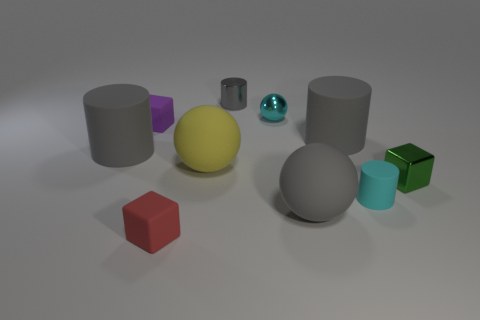Which object stands out the most to you and why? The yellow sphere stands out the most. Its vibrant color contrasts sharply with the muted tones of the other objects and the neutral background, capturing attention immediately. What might be the purpose of this collection of objects? This collection of objects could serve several purposes; it might be a 3D rendering test demonstrating lighting, shading, and texture effects. It could also be an educational tool to teach about shapes, colors, and materials. 